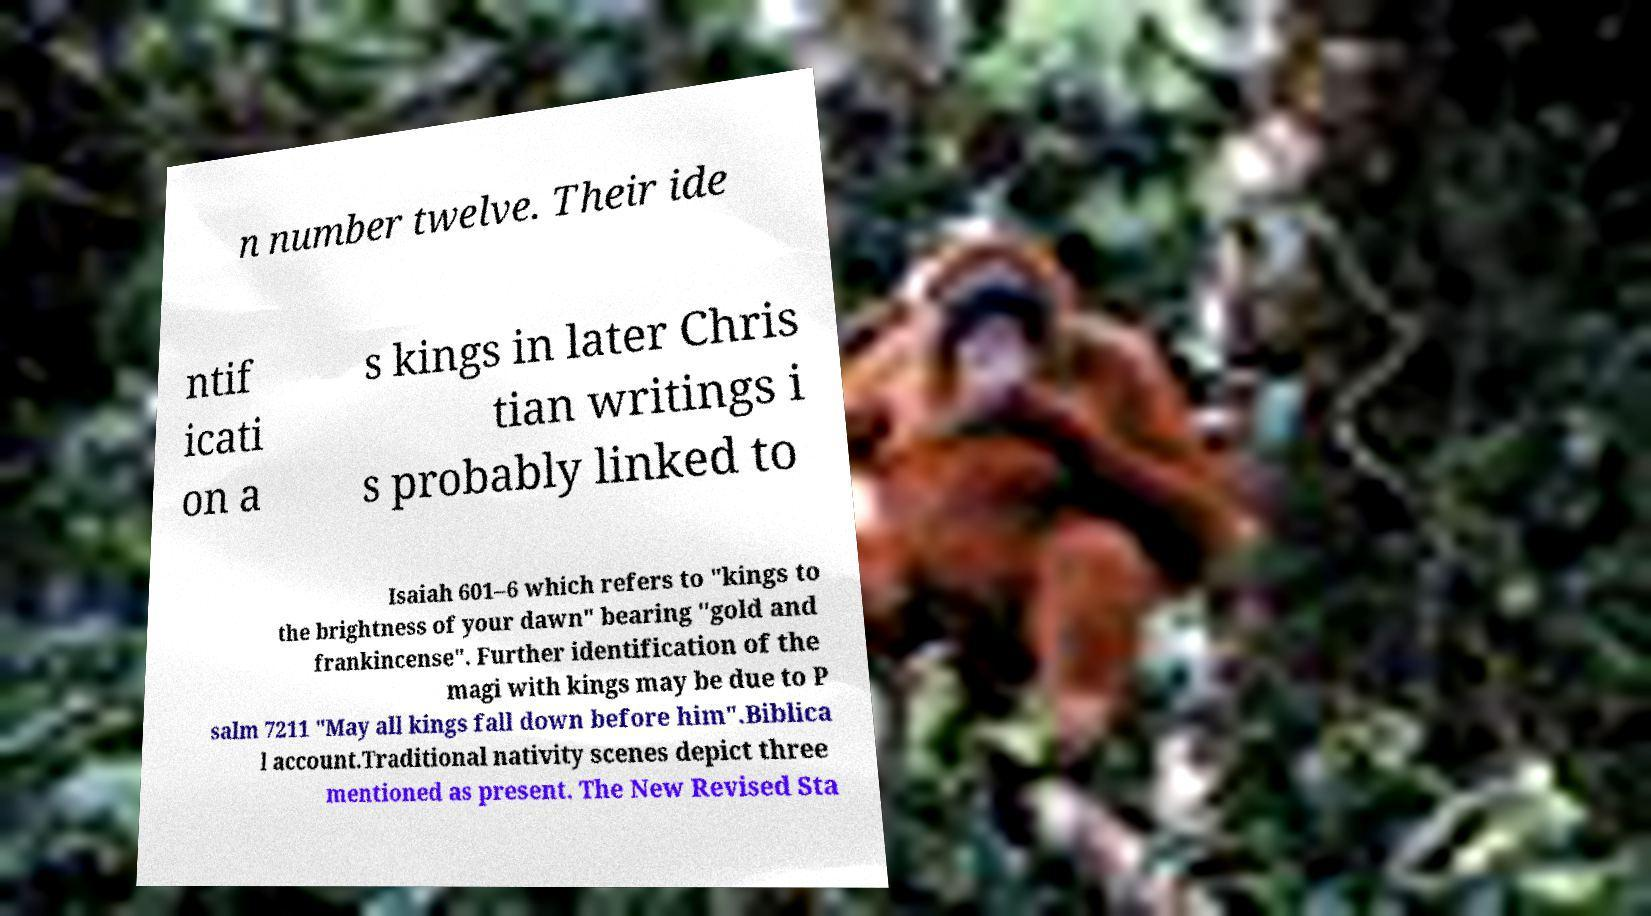I need the written content from this picture converted into text. Can you do that? n number twelve. Their ide ntif icati on a s kings in later Chris tian writings i s probably linked to Isaiah 601–6 which refers to "kings to the brightness of your dawn" bearing "gold and frankincense". Further identification of the magi with kings may be due to P salm 7211 "May all kings fall down before him".Biblica l account.Traditional nativity scenes depict three mentioned as present. The New Revised Sta 